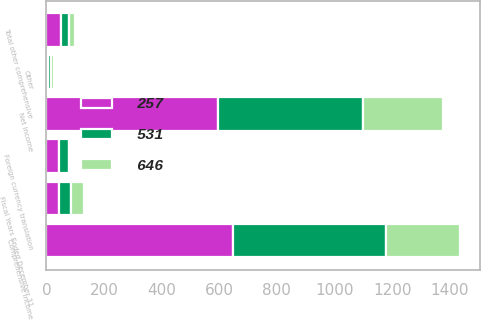Convert chart to OTSL. <chart><loc_0><loc_0><loc_500><loc_500><stacked_bar_chart><ecel><fcel>Fiscal Years Ended December 31<fcel>Net income<fcel>Foreign currency translation<fcel>Other<fcel>Total other comprehensive<fcel>Comprehensive income<nl><fcel>257<fcel>43<fcel>596<fcel>43<fcel>7<fcel>50<fcel>646<nl><fcel>531<fcel>43<fcel>502<fcel>37<fcel>8<fcel>29<fcel>531<nl><fcel>646<fcel>43<fcel>277<fcel>7<fcel>13<fcel>20<fcel>257<nl></chart> 